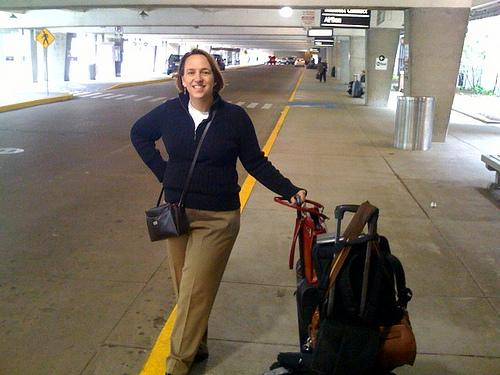What is she doing? posing 